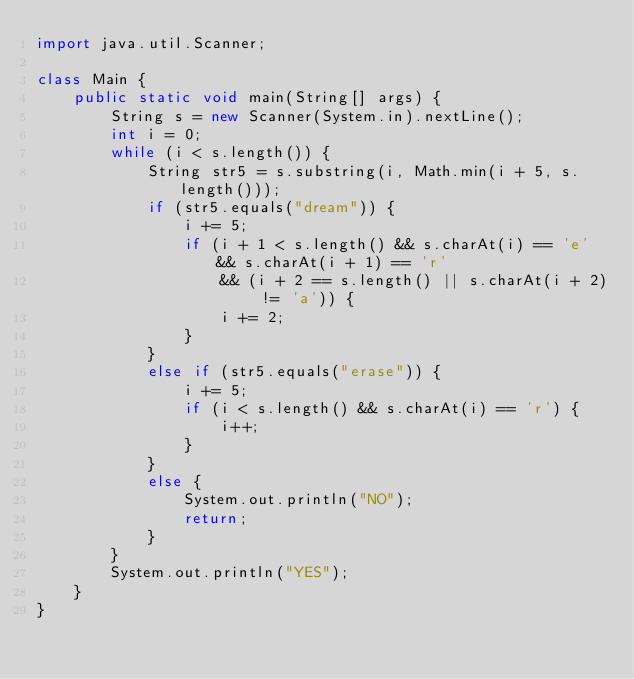Convert code to text. <code><loc_0><loc_0><loc_500><loc_500><_Java_>import java.util.Scanner;

class Main {
    public static void main(String[] args) {
        String s = new Scanner(System.in).nextLine();
        int i = 0;
        while (i < s.length()) {
            String str5 = s.substring(i, Math.min(i + 5, s.length()));
            if (str5.equals("dream")) {
                i += 5;
                if (i + 1 < s.length() && s.charAt(i) == 'e' && s.charAt(i + 1) == 'r'
                    && (i + 2 == s.length() || s.charAt(i + 2) != 'a')) {
                    i += 2;
                }
            }
            else if (str5.equals("erase")) {
                i += 5;
                if (i < s.length() && s.charAt(i) == 'r') {
                    i++;
                }
            }
            else {
                System.out.println("NO");
                return;
            }
        }
        System.out.println("YES");
    }
}
</code> 